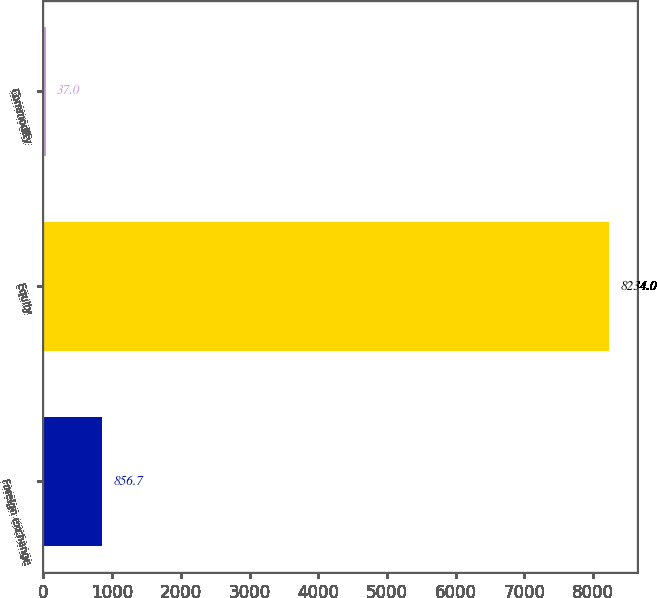<chart> <loc_0><loc_0><loc_500><loc_500><bar_chart><fcel>Foreign exchange<fcel>Equity<fcel>Commodity<nl><fcel>856.7<fcel>8234<fcel>37<nl></chart> 